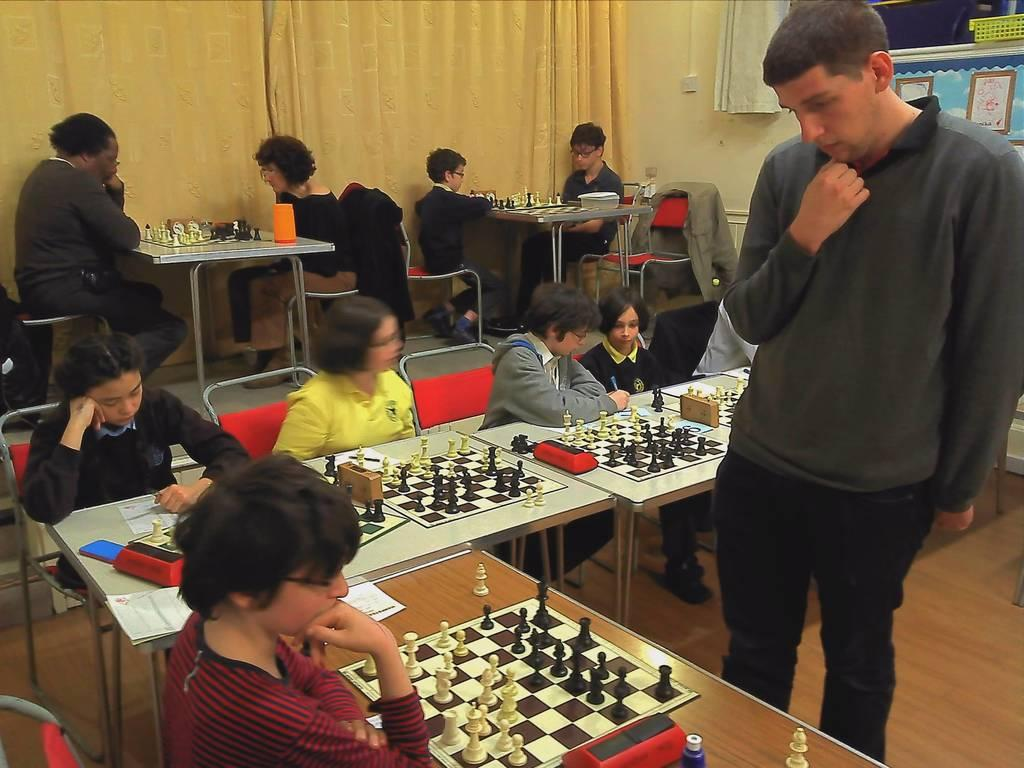What are the people in the image doing? They are playing chess. How are the people sitting in the image? They are sitting on chairs. What is the standing person doing in the image? The standing person is observing the chess board. What type of cream can be seen on the chess board in the image? There is no cream present on the chess board in the image. What shape is the knot tied by the chess pieces in the image? There are no knots tied by the chess pieces in the image, as they are game pieces used for playing chess. 